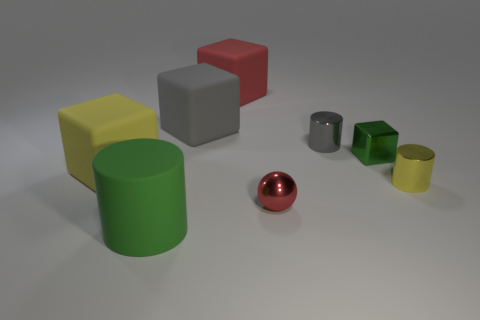Add 1 large red matte things. How many objects exist? 9 Subtract all cylinders. How many objects are left? 5 Subtract 0 cyan spheres. How many objects are left? 8 Subtract all small gray cylinders. Subtract all big red matte objects. How many objects are left? 6 Add 6 red shiny balls. How many red shiny balls are left? 7 Add 5 yellow cylinders. How many yellow cylinders exist? 6 